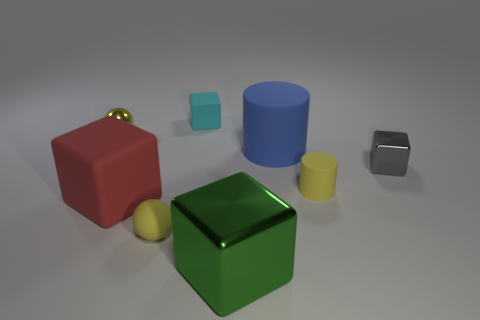Is there a small cyan block made of the same material as the tiny cyan thing?
Offer a very short reply. No. How many metallic objects are either yellow cylinders or balls?
Your response must be concise. 1. The green metallic object that is in front of the rubber block that is in front of the metallic sphere is what shape?
Make the answer very short. Cube. Is the number of small gray blocks left of the red thing less than the number of small yellow cylinders?
Make the answer very short. Yes. The cyan matte object is what shape?
Give a very brief answer. Cube. There is a block that is to the left of the cyan matte cube; what is its size?
Your answer should be compact. Large. There is another matte object that is the same size as the blue object; what color is it?
Provide a short and direct response. Red. Are there any tiny matte balls that have the same color as the big rubber cube?
Provide a short and direct response. No. Are there fewer big blue rubber cylinders to the left of the big red object than large blue cylinders that are in front of the big shiny object?
Give a very brief answer. No. The small yellow thing that is both right of the small yellow metallic sphere and behind the big red rubber cube is made of what material?
Give a very brief answer. Rubber. 